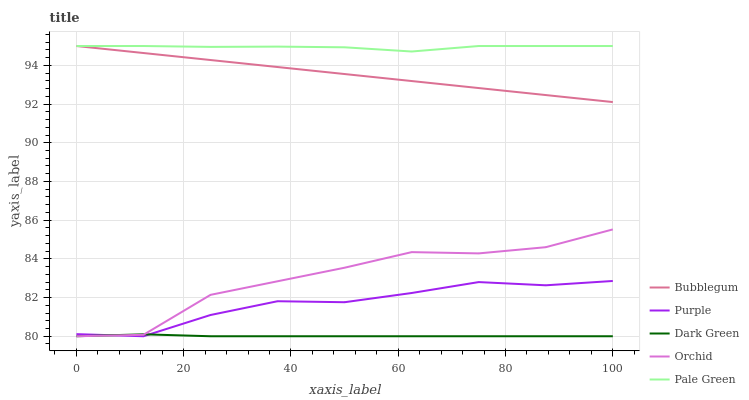Does Orchid have the minimum area under the curve?
Answer yes or no. No. Does Orchid have the maximum area under the curve?
Answer yes or no. No. Is Pale Green the smoothest?
Answer yes or no. No. Is Pale Green the roughest?
Answer yes or no. No. Does Pale Green have the lowest value?
Answer yes or no. No. Does Orchid have the highest value?
Answer yes or no. No. Is Dark Green less than Pale Green?
Answer yes or no. Yes. Is Bubblegum greater than Purple?
Answer yes or no. Yes. Does Dark Green intersect Pale Green?
Answer yes or no. No. 